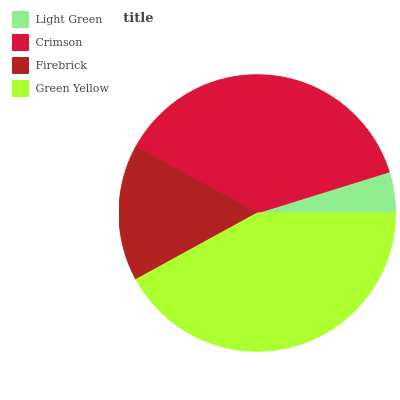Is Light Green the minimum?
Answer yes or no. Yes. Is Green Yellow the maximum?
Answer yes or no. Yes. Is Crimson the minimum?
Answer yes or no. No. Is Crimson the maximum?
Answer yes or no. No. Is Crimson greater than Light Green?
Answer yes or no. Yes. Is Light Green less than Crimson?
Answer yes or no. Yes. Is Light Green greater than Crimson?
Answer yes or no. No. Is Crimson less than Light Green?
Answer yes or no. No. Is Crimson the high median?
Answer yes or no. Yes. Is Firebrick the low median?
Answer yes or no. Yes. Is Green Yellow the high median?
Answer yes or no. No. Is Green Yellow the low median?
Answer yes or no. No. 